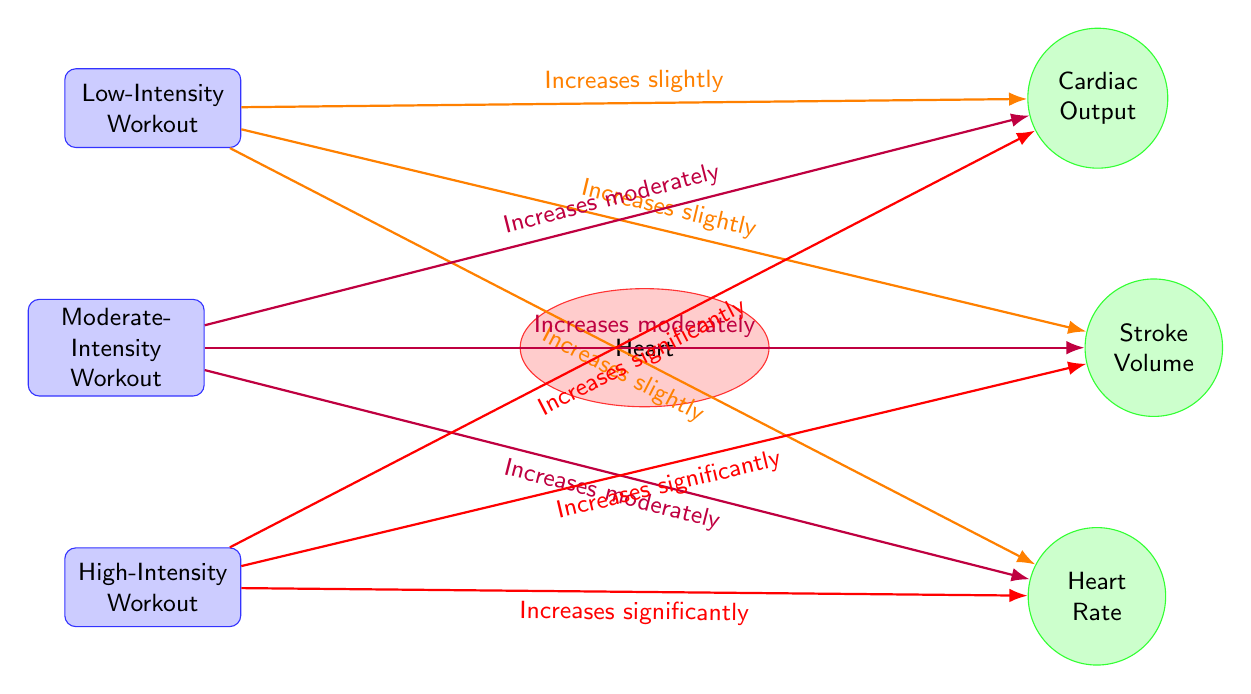What happens to cardiac output during high-intensity workouts? The diagram shows that during high-intensity workouts, cardiac output increases significantly, as indicated by the red arrow pointing from the high-intensity workout node to the cardiac output node.
Answer: Increases significantly What is the relationship between moderate-intensity workouts and heart rate? According to the diagram, moderate-intensity workouts lead to a moderate increase in heart rate, which can be seen by the purple arrow connecting the moderate-intensity workout node to the heart rate node.
Answer: Increases moderately How many types of workouts are displayed in the diagram? The diagram features three types of workouts: low-intensity, moderate-intensity, and high-intensity, listed above and below the heart node. Counting these provides the total number of workout types.
Answer: Three What change occurs in stroke volume with low-intensity workouts? The diagram indicates that low-intensity workouts cause a slight increase in stroke volume, as represented by the orange arrow from the low-intensity workout to the stroke volume metric.
Answer: Increases slightly Which workout type leads to the most significant increase in all three metrics? The diagram shows that high-intensity workouts lead to a significant increase in cardiac output, stroke volume, and heart rate, as highlighted by the red arrows extending from the high-intensity workout node to each metric.
Answer: High-intensity workout What color indicates the effect of low-intensity workouts on heart rate? In the diagram, the effect of low-intensity workouts on heart rate is represented by an orange arrow, signifying the slight increase indicated in the flow from the low-intensity workout to the heart rate node.
Answer: Orange What does the purple color represent in this diagram? The purple color in the diagram indicates the moderate increase in all metrics associated with moderate-intensity workouts, evident from the purple arrows leading to cardiac output, stroke volume, and heart rate.
Answer: Moderate increase How does heart rate change with high-intensity workouts? The diagram illustrates that heart rate increases significantly during high-intensity workouts, indicated by the red arrow that connects the high-intensity workout node to the heart rate node.
Answer: Increases significantly 